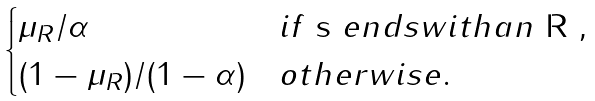Convert formula to latex. <formula><loc_0><loc_0><loc_500><loc_500>\begin{cases} \mu _ { R } / \alpha & i f $ s $ e n d s w i t h a n $ R $ , \\ ( 1 - \mu _ { R } ) / ( 1 - \alpha ) & o t h e r w i s e . \end{cases}</formula> 